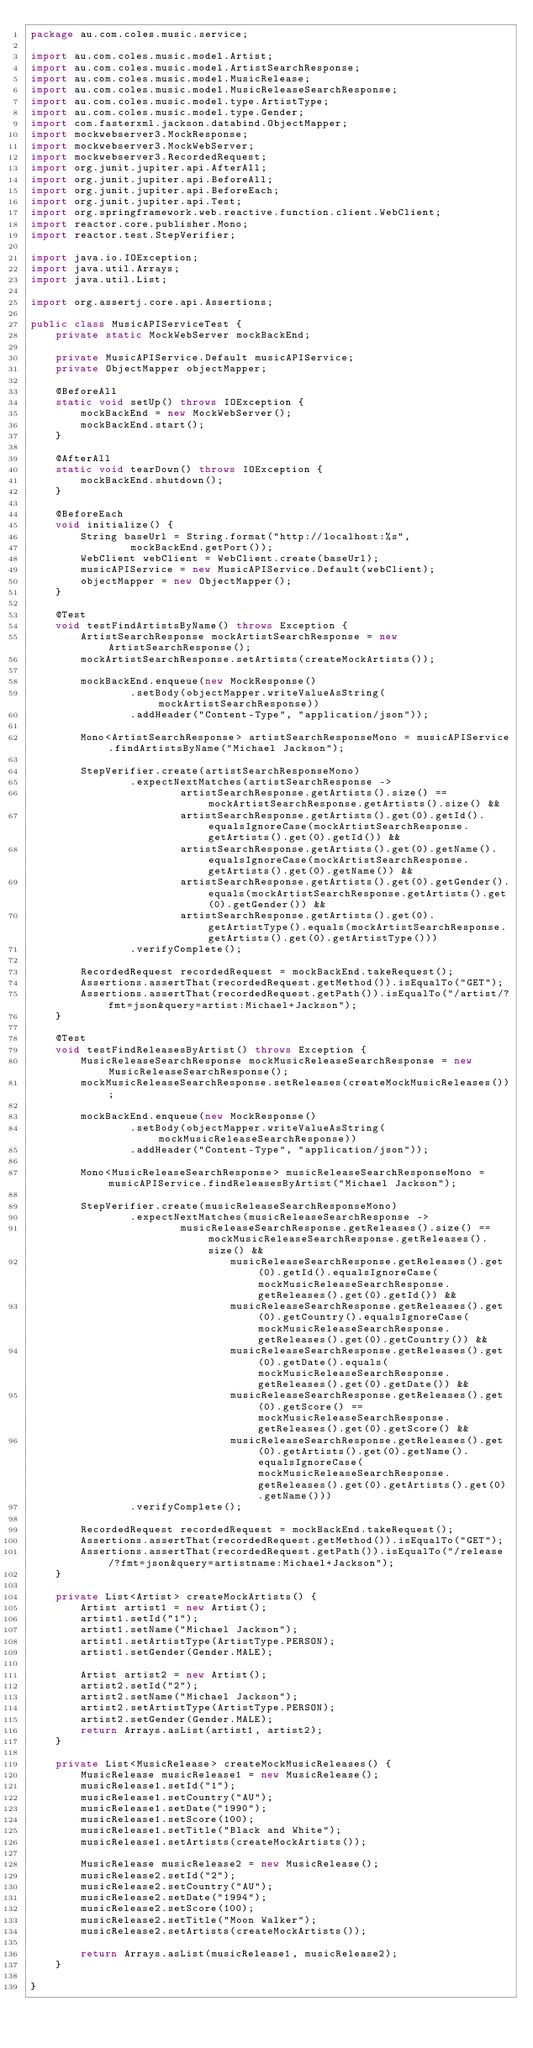<code> <loc_0><loc_0><loc_500><loc_500><_Java_>package au.com.coles.music.service;

import au.com.coles.music.model.Artist;
import au.com.coles.music.model.ArtistSearchResponse;
import au.com.coles.music.model.MusicRelease;
import au.com.coles.music.model.MusicReleaseSearchResponse;
import au.com.coles.music.model.type.ArtistType;
import au.com.coles.music.model.type.Gender;
import com.fasterxml.jackson.databind.ObjectMapper;
import mockwebserver3.MockResponse;
import mockwebserver3.MockWebServer;
import mockwebserver3.RecordedRequest;
import org.junit.jupiter.api.AfterAll;
import org.junit.jupiter.api.BeforeAll;
import org.junit.jupiter.api.BeforeEach;
import org.junit.jupiter.api.Test;
import org.springframework.web.reactive.function.client.WebClient;
import reactor.core.publisher.Mono;
import reactor.test.StepVerifier;

import java.io.IOException;
import java.util.Arrays;
import java.util.List;

import org.assertj.core.api.Assertions;

public class MusicAPIServiceTest {
    private static MockWebServer mockBackEnd;

    private MusicAPIService.Default musicAPIService;
    private ObjectMapper objectMapper;

    @BeforeAll
    static void setUp() throws IOException {
        mockBackEnd = new MockWebServer();
        mockBackEnd.start();
    }

    @AfterAll
    static void tearDown() throws IOException {
        mockBackEnd.shutdown();
    }

    @BeforeEach
    void initialize() {
        String baseUrl = String.format("http://localhost:%s",
                mockBackEnd.getPort());
        WebClient webClient = WebClient.create(baseUrl);
        musicAPIService = new MusicAPIService.Default(webClient);
        objectMapper = new ObjectMapper();
    }

    @Test
    void testFindArtistsByName() throws Exception {
        ArtistSearchResponse mockArtistSearchResponse = new ArtistSearchResponse();
        mockArtistSearchResponse.setArtists(createMockArtists());

        mockBackEnd.enqueue(new MockResponse()
                .setBody(objectMapper.writeValueAsString(mockArtistSearchResponse))
                .addHeader("Content-Type", "application/json"));

        Mono<ArtistSearchResponse> artistSearchResponseMono = musicAPIService.findArtistsByName("Michael Jackson");

        StepVerifier.create(artistSearchResponseMono)
                .expectNextMatches(artistSearchResponse ->
                        artistSearchResponse.getArtists().size() == mockArtistSearchResponse.getArtists().size() &&
                        artistSearchResponse.getArtists().get(0).getId().equalsIgnoreCase(mockArtistSearchResponse.getArtists().get(0).getId()) &&
                        artistSearchResponse.getArtists().get(0).getName().equalsIgnoreCase(mockArtistSearchResponse.getArtists().get(0).getName()) &&
                        artistSearchResponse.getArtists().get(0).getGender().equals(mockArtistSearchResponse.getArtists().get(0).getGender()) &&
                        artistSearchResponse.getArtists().get(0).getArtistType().equals(mockArtistSearchResponse.getArtists().get(0).getArtistType()))
                .verifyComplete();

        RecordedRequest recordedRequest = mockBackEnd.takeRequest();
        Assertions.assertThat(recordedRequest.getMethod()).isEqualTo("GET");
        Assertions.assertThat(recordedRequest.getPath()).isEqualTo("/artist/?fmt=json&query=artist:Michael+Jackson");
    }

    @Test
    void testFindReleasesByArtist() throws Exception {
        MusicReleaseSearchResponse mockMusicReleaseSearchResponse = new MusicReleaseSearchResponse();
        mockMusicReleaseSearchResponse.setReleases(createMockMusicReleases());

        mockBackEnd.enqueue(new MockResponse()
                .setBody(objectMapper.writeValueAsString(mockMusicReleaseSearchResponse))
                .addHeader("Content-Type", "application/json"));

        Mono<MusicReleaseSearchResponse> musicReleaseSearchResponseMono = musicAPIService.findReleasesByArtist("Michael Jackson");

        StepVerifier.create(musicReleaseSearchResponseMono)
                .expectNextMatches(musicReleaseSearchResponse ->
                        musicReleaseSearchResponse.getReleases().size() == mockMusicReleaseSearchResponse.getReleases().size() &&
                                musicReleaseSearchResponse.getReleases().get(0).getId().equalsIgnoreCase(mockMusicReleaseSearchResponse.getReleases().get(0).getId()) &&
                                musicReleaseSearchResponse.getReleases().get(0).getCountry().equalsIgnoreCase(mockMusicReleaseSearchResponse.getReleases().get(0).getCountry()) &&
                                musicReleaseSearchResponse.getReleases().get(0).getDate().equals(mockMusicReleaseSearchResponse.getReleases().get(0).getDate()) &&
                                musicReleaseSearchResponse.getReleases().get(0).getScore() == mockMusicReleaseSearchResponse.getReleases().get(0).getScore() &&
                                musicReleaseSearchResponse.getReleases().get(0).getArtists().get(0).getName().equalsIgnoreCase(mockMusicReleaseSearchResponse.getReleases().get(0).getArtists().get(0).getName()))
                .verifyComplete();

        RecordedRequest recordedRequest = mockBackEnd.takeRequest();
        Assertions.assertThat(recordedRequest.getMethod()).isEqualTo("GET");
        Assertions.assertThat(recordedRequest.getPath()).isEqualTo("/release/?fmt=json&query=artistname:Michael+Jackson");
    }

    private List<Artist> createMockArtists() {
        Artist artist1 = new Artist();
        artist1.setId("1");
        artist1.setName("Michael Jackson");
        artist1.setArtistType(ArtistType.PERSON);
        artist1.setGender(Gender.MALE);

        Artist artist2 = new Artist();
        artist2.setId("2");
        artist2.setName("Michael Jackson");
        artist2.setArtistType(ArtistType.PERSON);
        artist2.setGender(Gender.MALE);
        return Arrays.asList(artist1, artist2);
    }

    private List<MusicRelease> createMockMusicReleases() {
        MusicRelease musicRelease1 = new MusicRelease();
        musicRelease1.setId("1");
        musicRelease1.setCountry("AU");
        musicRelease1.setDate("1990");
        musicRelease1.setScore(100);
        musicRelease1.setTitle("Black and White");
        musicRelease1.setArtists(createMockArtists());

        MusicRelease musicRelease2 = new MusicRelease();
        musicRelease2.setId("2");
        musicRelease2.setCountry("AU");
        musicRelease2.setDate("1994");
        musicRelease2.setScore(100);
        musicRelease2.setTitle("Moon Walker");
        musicRelease2.setArtists(createMockArtists());

        return Arrays.asList(musicRelease1, musicRelease2);
    }

}
</code> 